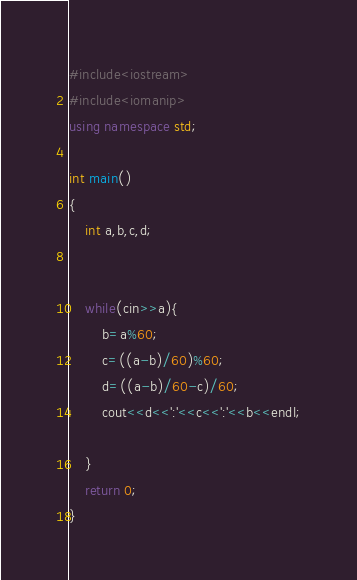Convert code to text. <code><loc_0><loc_0><loc_500><loc_500><_C++_>#include<iostream>
#include<iomanip>
using namespace std;

int main()
{
	int a,b,c,d;
	

	while(cin>>a){
		b=a%60;
		c=((a-b)/60)%60;
		d=((a-b)/60-c)/60;
		cout<<d<<':'<<c<<':'<<b<<endl;
	
	}
	return 0;
}</code> 